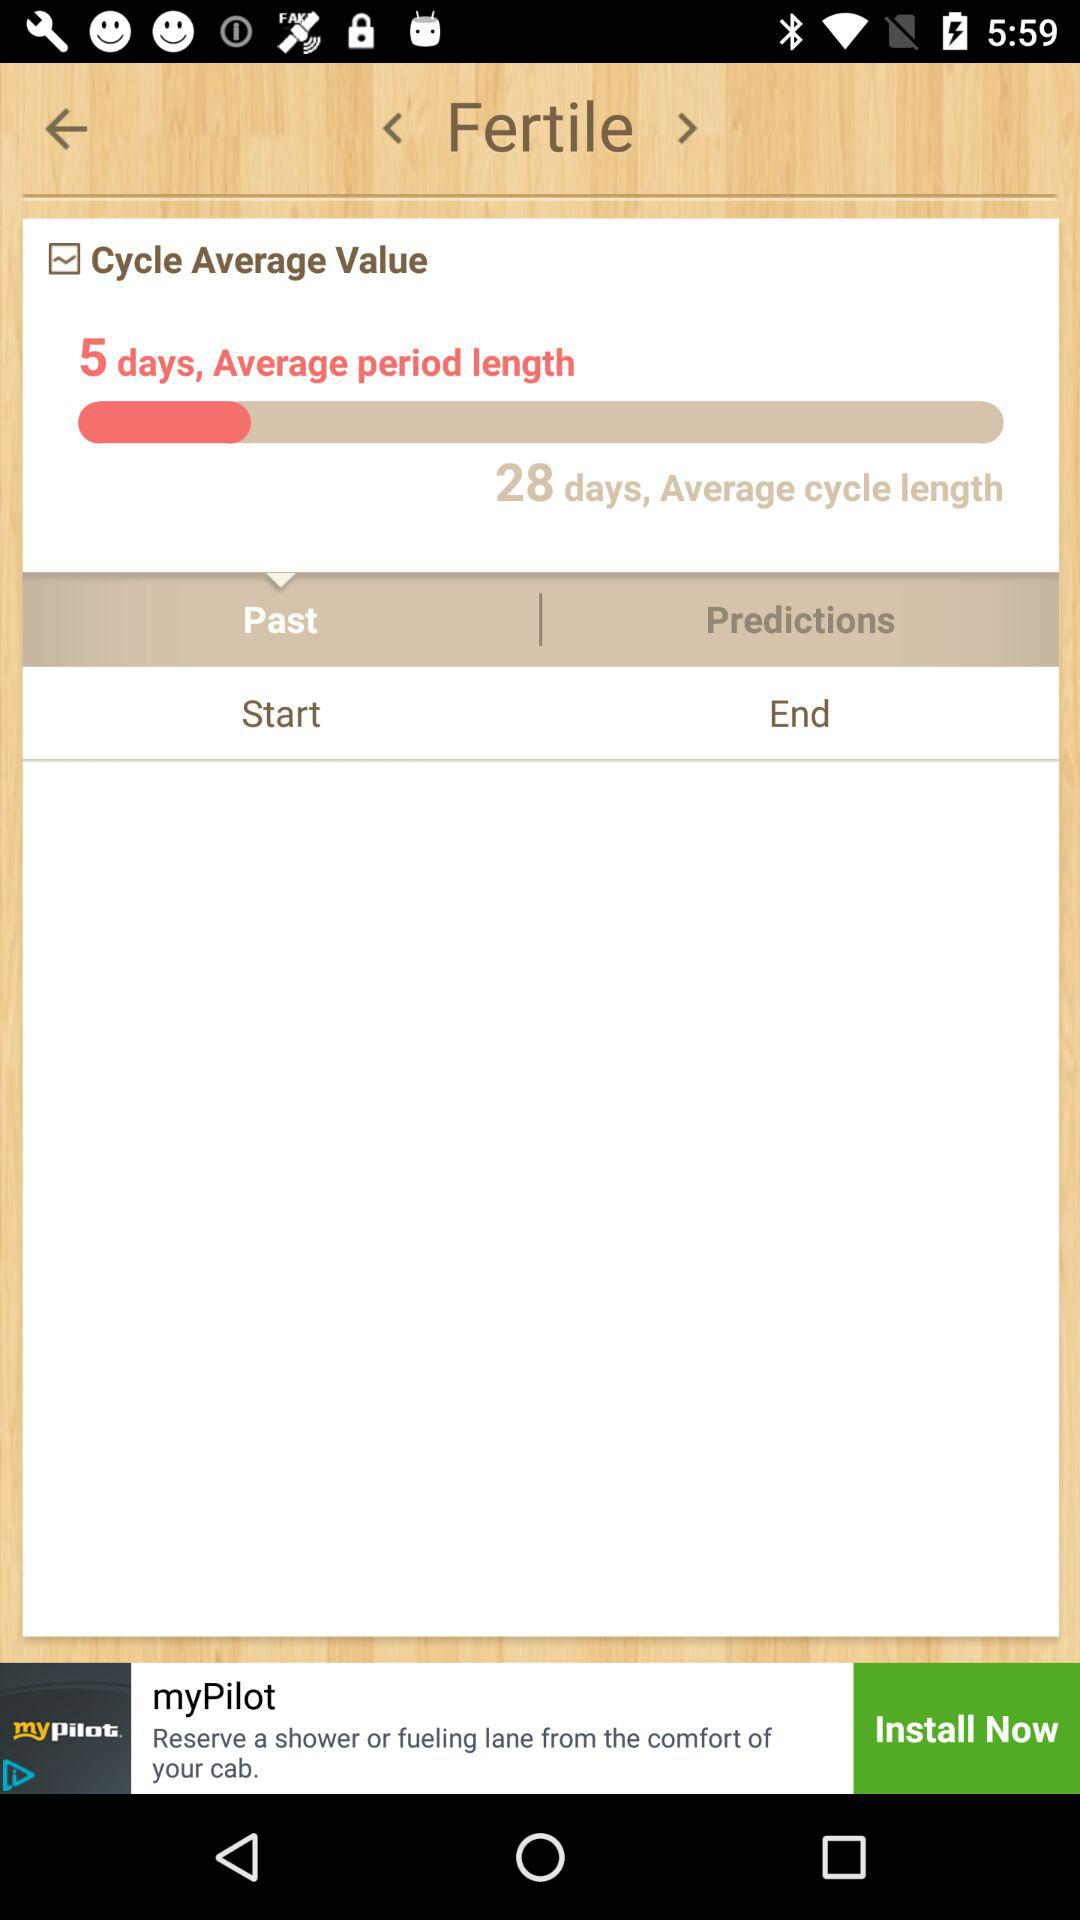Which option is selected? The selected option is "Past". 